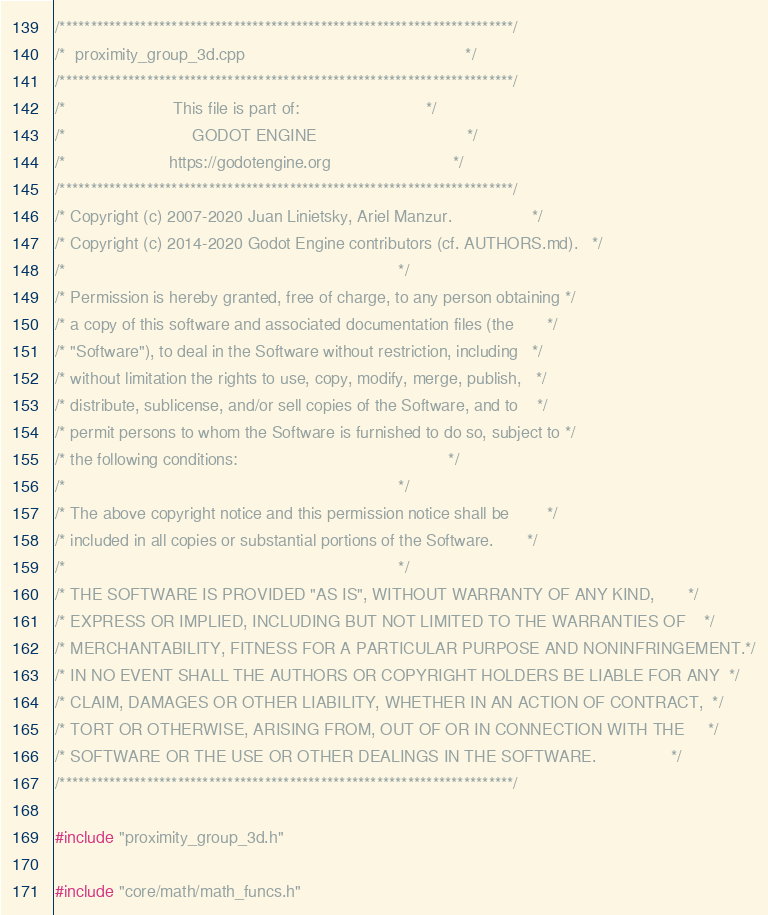Convert code to text. <code><loc_0><loc_0><loc_500><loc_500><_C++_>/*************************************************************************/
/*  proximity_group_3d.cpp                                               */
/*************************************************************************/
/*                       This file is part of:                           */
/*                           GODOT ENGINE                                */
/*                      https://godotengine.org                          */
/*************************************************************************/
/* Copyright (c) 2007-2020 Juan Linietsky, Ariel Manzur.                 */
/* Copyright (c) 2014-2020 Godot Engine contributors (cf. AUTHORS.md).   */
/*                                                                       */
/* Permission is hereby granted, free of charge, to any person obtaining */
/* a copy of this software and associated documentation files (the       */
/* "Software"), to deal in the Software without restriction, including   */
/* without limitation the rights to use, copy, modify, merge, publish,   */
/* distribute, sublicense, and/or sell copies of the Software, and to    */
/* permit persons to whom the Software is furnished to do so, subject to */
/* the following conditions:                                             */
/*                                                                       */
/* The above copyright notice and this permission notice shall be        */
/* included in all copies or substantial portions of the Software.       */
/*                                                                       */
/* THE SOFTWARE IS PROVIDED "AS IS", WITHOUT WARRANTY OF ANY KIND,       */
/* EXPRESS OR IMPLIED, INCLUDING BUT NOT LIMITED TO THE WARRANTIES OF    */
/* MERCHANTABILITY, FITNESS FOR A PARTICULAR PURPOSE AND NONINFRINGEMENT.*/
/* IN NO EVENT SHALL THE AUTHORS OR COPYRIGHT HOLDERS BE LIABLE FOR ANY  */
/* CLAIM, DAMAGES OR OTHER LIABILITY, WHETHER IN AN ACTION OF CONTRACT,  */
/* TORT OR OTHERWISE, ARISING FROM, OUT OF OR IN CONNECTION WITH THE     */
/* SOFTWARE OR THE USE OR OTHER DEALINGS IN THE SOFTWARE.                */
/*************************************************************************/

#include "proximity_group_3d.h"

#include "core/math/math_funcs.h"
</code> 